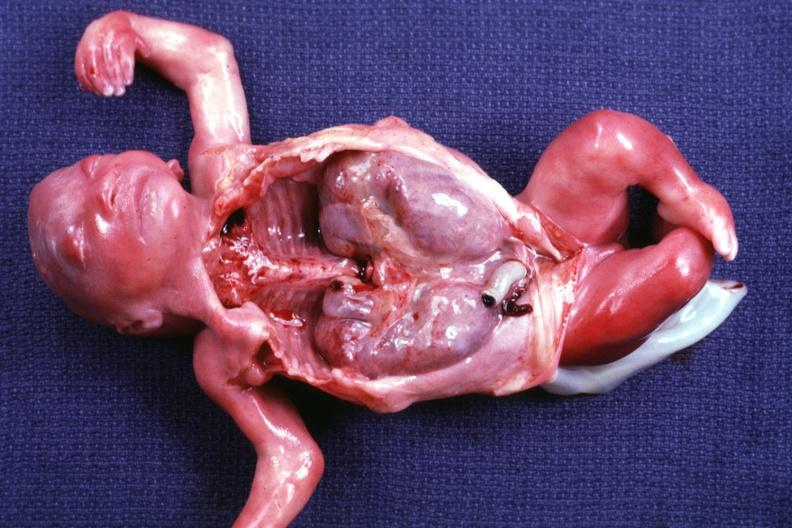what is present of kidneys?
Answer the question using a single word or phrase. Polycystic disease 